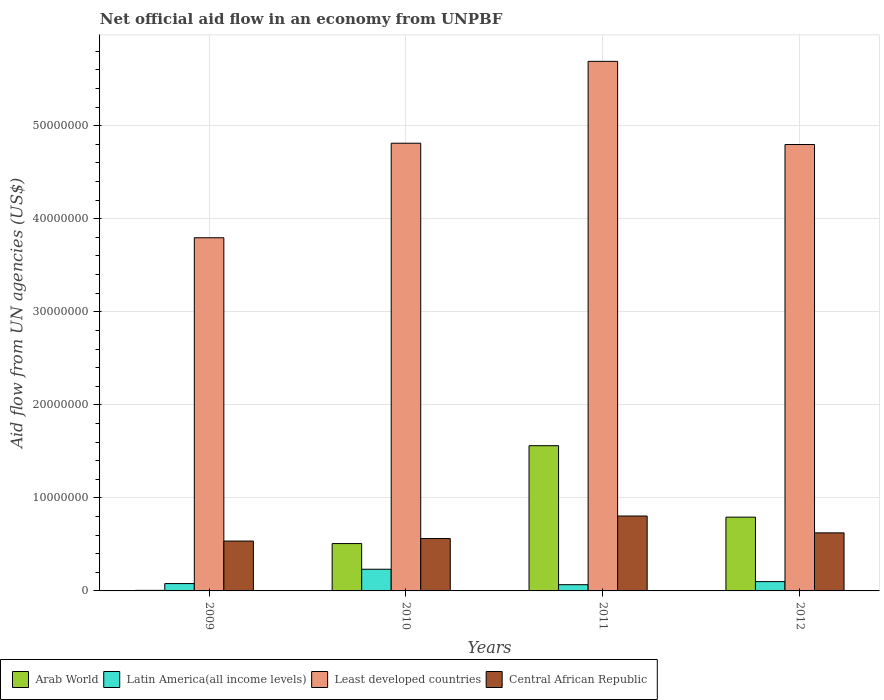How many different coloured bars are there?
Ensure brevity in your answer.  4. How many groups of bars are there?
Offer a very short reply. 4. Are the number of bars per tick equal to the number of legend labels?
Offer a very short reply. Yes. Are the number of bars on each tick of the X-axis equal?
Offer a very short reply. Yes. How many bars are there on the 2nd tick from the left?
Ensure brevity in your answer.  4. What is the label of the 2nd group of bars from the left?
Provide a succinct answer. 2010. In how many cases, is the number of bars for a given year not equal to the number of legend labels?
Your response must be concise. 0. What is the net official aid flow in Central African Republic in 2009?
Offer a very short reply. 5.36e+06. Across all years, what is the maximum net official aid flow in Least developed countries?
Offer a terse response. 5.69e+07. Across all years, what is the minimum net official aid flow in Latin America(all income levels)?
Ensure brevity in your answer.  6.70e+05. In which year was the net official aid flow in Arab World maximum?
Provide a short and direct response. 2011. What is the total net official aid flow in Least developed countries in the graph?
Ensure brevity in your answer.  1.91e+08. What is the difference between the net official aid flow in Central African Republic in 2011 and that in 2012?
Offer a very short reply. 1.81e+06. What is the difference between the net official aid flow in Least developed countries in 2010 and the net official aid flow in Central African Republic in 2009?
Keep it short and to the point. 4.28e+07. What is the average net official aid flow in Arab World per year?
Offer a very short reply. 7.17e+06. In the year 2012, what is the difference between the net official aid flow in Central African Republic and net official aid flow in Latin America(all income levels)?
Your response must be concise. 5.24e+06. What is the ratio of the net official aid flow in Least developed countries in 2011 to that in 2012?
Offer a very short reply. 1.19. What is the difference between the highest and the second highest net official aid flow in Central African Republic?
Your response must be concise. 1.81e+06. What is the difference between the highest and the lowest net official aid flow in Least developed countries?
Your answer should be compact. 1.90e+07. In how many years, is the net official aid flow in Arab World greater than the average net official aid flow in Arab World taken over all years?
Your answer should be compact. 2. Is the sum of the net official aid flow in Latin America(all income levels) in 2011 and 2012 greater than the maximum net official aid flow in Arab World across all years?
Provide a short and direct response. No. What does the 4th bar from the left in 2011 represents?
Provide a short and direct response. Central African Republic. What does the 4th bar from the right in 2009 represents?
Provide a short and direct response. Arab World. Is it the case that in every year, the sum of the net official aid flow in Least developed countries and net official aid flow in Latin America(all income levels) is greater than the net official aid flow in Central African Republic?
Offer a terse response. Yes. How many bars are there?
Keep it short and to the point. 16. What is the difference between two consecutive major ticks on the Y-axis?
Ensure brevity in your answer.  1.00e+07. Does the graph contain any zero values?
Your answer should be compact. No. Does the graph contain grids?
Keep it short and to the point. Yes. Where does the legend appear in the graph?
Your answer should be compact. Bottom left. How many legend labels are there?
Ensure brevity in your answer.  4. How are the legend labels stacked?
Your answer should be very brief. Horizontal. What is the title of the graph?
Offer a terse response. Net official aid flow in an economy from UNPBF. Does "Niger" appear as one of the legend labels in the graph?
Ensure brevity in your answer.  No. What is the label or title of the X-axis?
Offer a terse response. Years. What is the label or title of the Y-axis?
Provide a succinct answer. Aid flow from UN agencies (US$). What is the Aid flow from UN agencies (US$) in Latin America(all income levels) in 2009?
Ensure brevity in your answer.  7.90e+05. What is the Aid flow from UN agencies (US$) of Least developed countries in 2009?
Your answer should be compact. 3.80e+07. What is the Aid flow from UN agencies (US$) in Central African Republic in 2009?
Offer a very short reply. 5.36e+06. What is the Aid flow from UN agencies (US$) in Arab World in 2010?
Offer a very short reply. 5.09e+06. What is the Aid flow from UN agencies (US$) in Latin America(all income levels) in 2010?
Give a very brief answer. 2.33e+06. What is the Aid flow from UN agencies (US$) of Least developed countries in 2010?
Give a very brief answer. 4.81e+07. What is the Aid flow from UN agencies (US$) of Central African Republic in 2010?
Give a very brief answer. 5.63e+06. What is the Aid flow from UN agencies (US$) in Arab World in 2011?
Offer a very short reply. 1.56e+07. What is the Aid flow from UN agencies (US$) in Latin America(all income levels) in 2011?
Provide a succinct answer. 6.70e+05. What is the Aid flow from UN agencies (US$) in Least developed countries in 2011?
Make the answer very short. 5.69e+07. What is the Aid flow from UN agencies (US$) in Central African Republic in 2011?
Your answer should be very brief. 8.05e+06. What is the Aid flow from UN agencies (US$) in Arab World in 2012?
Offer a very short reply. 7.93e+06. What is the Aid flow from UN agencies (US$) in Latin America(all income levels) in 2012?
Your answer should be compact. 1.00e+06. What is the Aid flow from UN agencies (US$) in Least developed countries in 2012?
Provide a short and direct response. 4.80e+07. What is the Aid flow from UN agencies (US$) in Central African Republic in 2012?
Provide a succinct answer. 6.24e+06. Across all years, what is the maximum Aid flow from UN agencies (US$) of Arab World?
Give a very brief answer. 1.56e+07. Across all years, what is the maximum Aid flow from UN agencies (US$) of Latin America(all income levels)?
Give a very brief answer. 2.33e+06. Across all years, what is the maximum Aid flow from UN agencies (US$) in Least developed countries?
Your answer should be compact. 5.69e+07. Across all years, what is the maximum Aid flow from UN agencies (US$) in Central African Republic?
Offer a terse response. 8.05e+06. Across all years, what is the minimum Aid flow from UN agencies (US$) of Arab World?
Make the answer very short. 6.00e+04. Across all years, what is the minimum Aid flow from UN agencies (US$) in Latin America(all income levels)?
Your answer should be compact. 6.70e+05. Across all years, what is the minimum Aid flow from UN agencies (US$) in Least developed countries?
Provide a succinct answer. 3.80e+07. Across all years, what is the minimum Aid flow from UN agencies (US$) in Central African Republic?
Keep it short and to the point. 5.36e+06. What is the total Aid flow from UN agencies (US$) in Arab World in the graph?
Provide a short and direct response. 2.87e+07. What is the total Aid flow from UN agencies (US$) in Latin America(all income levels) in the graph?
Your answer should be very brief. 4.79e+06. What is the total Aid flow from UN agencies (US$) of Least developed countries in the graph?
Offer a terse response. 1.91e+08. What is the total Aid flow from UN agencies (US$) in Central African Republic in the graph?
Your answer should be compact. 2.53e+07. What is the difference between the Aid flow from UN agencies (US$) in Arab World in 2009 and that in 2010?
Give a very brief answer. -5.03e+06. What is the difference between the Aid flow from UN agencies (US$) of Latin America(all income levels) in 2009 and that in 2010?
Keep it short and to the point. -1.54e+06. What is the difference between the Aid flow from UN agencies (US$) in Least developed countries in 2009 and that in 2010?
Your answer should be very brief. -1.02e+07. What is the difference between the Aid flow from UN agencies (US$) of Central African Republic in 2009 and that in 2010?
Offer a terse response. -2.70e+05. What is the difference between the Aid flow from UN agencies (US$) of Arab World in 2009 and that in 2011?
Make the answer very short. -1.56e+07. What is the difference between the Aid flow from UN agencies (US$) of Least developed countries in 2009 and that in 2011?
Your answer should be compact. -1.90e+07. What is the difference between the Aid flow from UN agencies (US$) in Central African Republic in 2009 and that in 2011?
Offer a very short reply. -2.69e+06. What is the difference between the Aid flow from UN agencies (US$) of Arab World in 2009 and that in 2012?
Provide a short and direct response. -7.87e+06. What is the difference between the Aid flow from UN agencies (US$) of Latin America(all income levels) in 2009 and that in 2012?
Your response must be concise. -2.10e+05. What is the difference between the Aid flow from UN agencies (US$) in Least developed countries in 2009 and that in 2012?
Keep it short and to the point. -1.00e+07. What is the difference between the Aid flow from UN agencies (US$) of Central African Republic in 2009 and that in 2012?
Provide a short and direct response. -8.80e+05. What is the difference between the Aid flow from UN agencies (US$) of Arab World in 2010 and that in 2011?
Ensure brevity in your answer.  -1.05e+07. What is the difference between the Aid flow from UN agencies (US$) of Latin America(all income levels) in 2010 and that in 2011?
Keep it short and to the point. 1.66e+06. What is the difference between the Aid flow from UN agencies (US$) in Least developed countries in 2010 and that in 2011?
Offer a terse response. -8.80e+06. What is the difference between the Aid flow from UN agencies (US$) in Central African Republic in 2010 and that in 2011?
Offer a terse response. -2.42e+06. What is the difference between the Aid flow from UN agencies (US$) of Arab World in 2010 and that in 2012?
Ensure brevity in your answer.  -2.84e+06. What is the difference between the Aid flow from UN agencies (US$) in Latin America(all income levels) in 2010 and that in 2012?
Offer a terse response. 1.33e+06. What is the difference between the Aid flow from UN agencies (US$) in Central African Republic in 2010 and that in 2012?
Provide a short and direct response. -6.10e+05. What is the difference between the Aid flow from UN agencies (US$) of Arab World in 2011 and that in 2012?
Provide a succinct answer. 7.68e+06. What is the difference between the Aid flow from UN agencies (US$) of Latin America(all income levels) in 2011 and that in 2012?
Offer a terse response. -3.30e+05. What is the difference between the Aid flow from UN agencies (US$) of Least developed countries in 2011 and that in 2012?
Your response must be concise. 8.94e+06. What is the difference between the Aid flow from UN agencies (US$) of Central African Republic in 2011 and that in 2012?
Offer a very short reply. 1.81e+06. What is the difference between the Aid flow from UN agencies (US$) in Arab World in 2009 and the Aid flow from UN agencies (US$) in Latin America(all income levels) in 2010?
Ensure brevity in your answer.  -2.27e+06. What is the difference between the Aid flow from UN agencies (US$) of Arab World in 2009 and the Aid flow from UN agencies (US$) of Least developed countries in 2010?
Offer a very short reply. -4.81e+07. What is the difference between the Aid flow from UN agencies (US$) in Arab World in 2009 and the Aid flow from UN agencies (US$) in Central African Republic in 2010?
Your response must be concise. -5.57e+06. What is the difference between the Aid flow from UN agencies (US$) in Latin America(all income levels) in 2009 and the Aid flow from UN agencies (US$) in Least developed countries in 2010?
Provide a succinct answer. -4.73e+07. What is the difference between the Aid flow from UN agencies (US$) in Latin America(all income levels) in 2009 and the Aid flow from UN agencies (US$) in Central African Republic in 2010?
Give a very brief answer. -4.84e+06. What is the difference between the Aid flow from UN agencies (US$) in Least developed countries in 2009 and the Aid flow from UN agencies (US$) in Central African Republic in 2010?
Your response must be concise. 3.23e+07. What is the difference between the Aid flow from UN agencies (US$) of Arab World in 2009 and the Aid flow from UN agencies (US$) of Latin America(all income levels) in 2011?
Your answer should be very brief. -6.10e+05. What is the difference between the Aid flow from UN agencies (US$) in Arab World in 2009 and the Aid flow from UN agencies (US$) in Least developed countries in 2011?
Offer a terse response. -5.69e+07. What is the difference between the Aid flow from UN agencies (US$) in Arab World in 2009 and the Aid flow from UN agencies (US$) in Central African Republic in 2011?
Offer a terse response. -7.99e+06. What is the difference between the Aid flow from UN agencies (US$) in Latin America(all income levels) in 2009 and the Aid flow from UN agencies (US$) in Least developed countries in 2011?
Provide a succinct answer. -5.61e+07. What is the difference between the Aid flow from UN agencies (US$) of Latin America(all income levels) in 2009 and the Aid flow from UN agencies (US$) of Central African Republic in 2011?
Offer a very short reply. -7.26e+06. What is the difference between the Aid flow from UN agencies (US$) of Least developed countries in 2009 and the Aid flow from UN agencies (US$) of Central African Republic in 2011?
Offer a terse response. 2.99e+07. What is the difference between the Aid flow from UN agencies (US$) in Arab World in 2009 and the Aid flow from UN agencies (US$) in Latin America(all income levels) in 2012?
Your response must be concise. -9.40e+05. What is the difference between the Aid flow from UN agencies (US$) in Arab World in 2009 and the Aid flow from UN agencies (US$) in Least developed countries in 2012?
Provide a succinct answer. -4.79e+07. What is the difference between the Aid flow from UN agencies (US$) of Arab World in 2009 and the Aid flow from UN agencies (US$) of Central African Republic in 2012?
Ensure brevity in your answer.  -6.18e+06. What is the difference between the Aid flow from UN agencies (US$) in Latin America(all income levels) in 2009 and the Aid flow from UN agencies (US$) in Least developed countries in 2012?
Provide a short and direct response. -4.72e+07. What is the difference between the Aid flow from UN agencies (US$) in Latin America(all income levels) in 2009 and the Aid flow from UN agencies (US$) in Central African Republic in 2012?
Offer a very short reply. -5.45e+06. What is the difference between the Aid flow from UN agencies (US$) in Least developed countries in 2009 and the Aid flow from UN agencies (US$) in Central African Republic in 2012?
Keep it short and to the point. 3.17e+07. What is the difference between the Aid flow from UN agencies (US$) in Arab World in 2010 and the Aid flow from UN agencies (US$) in Latin America(all income levels) in 2011?
Provide a succinct answer. 4.42e+06. What is the difference between the Aid flow from UN agencies (US$) in Arab World in 2010 and the Aid flow from UN agencies (US$) in Least developed countries in 2011?
Offer a very short reply. -5.18e+07. What is the difference between the Aid flow from UN agencies (US$) in Arab World in 2010 and the Aid flow from UN agencies (US$) in Central African Republic in 2011?
Your response must be concise. -2.96e+06. What is the difference between the Aid flow from UN agencies (US$) of Latin America(all income levels) in 2010 and the Aid flow from UN agencies (US$) of Least developed countries in 2011?
Provide a succinct answer. -5.46e+07. What is the difference between the Aid flow from UN agencies (US$) of Latin America(all income levels) in 2010 and the Aid flow from UN agencies (US$) of Central African Republic in 2011?
Your answer should be compact. -5.72e+06. What is the difference between the Aid flow from UN agencies (US$) of Least developed countries in 2010 and the Aid flow from UN agencies (US$) of Central African Republic in 2011?
Provide a succinct answer. 4.01e+07. What is the difference between the Aid flow from UN agencies (US$) in Arab World in 2010 and the Aid flow from UN agencies (US$) in Latin America(all income levels) in 2012?
Provide a succinct answer. 4.09e+06. What is the difference between the Aid flow from UN agencies (US$) in Arab World in 2010 and the Aid flow from UN agencies (US$) in Least developed countries in 2012?
Give a very brief answer. -4.29e+07. What is the difference between the Aid flow from UN agencies (US$) in Arab World in 2010 and the Aid flow from UN agencies (US$) in Central African Republic in 2012?
Offer a very short reply. -1.15e+06. What is the difference between the Aid flow from UN agencies (US$) of Latin America(all income levels) in 2010 and the Aid flow from UN agencies (US$) of Least developed countries in 2012?
Your answer should be compact. -4.56e+07. What is the difference between the Aid flow from UN agencies (US$) of Latin America(all income levels) in 2010 and the Aid flow from UN agencies (US$) of Central African Republic in 2012?
Your answer should be compact. -3.91e+06. What is the difference between the Aid flow from UN agencies (US$) of Least developed countries in 2010 and the Aid flow from UN agencies (US$) of Central African Republic in 2012?
Make the answer very short. 4.19e+07. What is the difference between the Aid flow from UN agencies (US$) in Arab World in 2011 and the Aid flow from UN agencies (US$) in Latin America(all income levels) in 2012?
Offer a terse response. 1.46e+07. What is the difference between the Aid flow from UN agencies (US$) of Arab World in 2011 and the Aid flow from UN agencies (US$) of Least developed countries in 2012?
Offer a terse response. -3.24e+07. What is the difference between the Aid flow from UN agencies (US$) in Arab World in 2011 and the Aid flow from UN agencies (US$) in Central African Republic in 2012?
Keep it short and to the point. 9.37e+06. What is the difference between the Aid flow from UN agencies (US$) in Latin America(all income levels) in 2011 and the Aid flow from UN agencies (US$) in Least developed countries in 2012?
Your response must be concise. -4.73e+07. What is the difference between the Aid flow from UN agencies (US$) of Latin America(all income levels) in 2011 and the Aid flow from UN agencies (US$) of Central African Republic in 2012?
Your response must be concise. -5.57e+06. What is the difference between the Aid flow from UN agencies (US$) of Least developed countries in 2011 and the Aid flow from UN agencies (US$) of Central African Republic in 2012?
Offer a terse response. 5.07e+07. What is the average Aid flow from UN agencies (US$) of Arab World per year?
Ensure brevity in your answer.  7.17e+06. What is the average Aid flow from UN agencies (US$) of Latin America(all income levels) per year?
Provide a succinct answer. 1.20e+06. What is the average Aid flow from UN agencies (US$) in Least developed countries per year?
Give a very brief answer. 4.77e+07. What is the average Aid flow from UN agencies (US$) in Central African Republic per year?
Give a very brief answer. 6.32e+06. In the year 2009, what is the difference between the Aid flow from UN agencies (US$) of Arab World and Aid flow from UN agencies (US$) of Latin America(all income levels)?
Keep it short and to the point. -7.30e+05. In the year 2009, what is the difference between the Aid flow from UN agencies (US$) of Arab World and Aid flow from UN agencies (US$) of Least developed countries?
Your answer should be compact. -3.79e+07. In the year 2009, what is the difference between the Aid flow from UN agencies (US$) in Arab World and Aid flow from UN agencies (US$) in Central African Republic?
Your answer should be very brief. -5.30e+06. In the year 2009, what is the difference between the Aid flow from UN agencies (US$) in Latin America(all income levels) and Aid flow from UN agencies (US$) in Least developed countries?
Keep it short and to the point. -3.72e+07. In the year 2009, what is the difference between the Aid flow from UN agencies (US$) of Latin America(all income levels) and Aid flow from UN agencies (US$) of Central African Republic?
Your answer should be compact. -4.57e+06. In the year 2009, what is the difference between the Aid flow from UN agencies (US$) of Least developed countries and Aid flow from UN agencies (US$) of Central African Republic?
Your answer should be compact. 3.26e+07. In the year 2010, what is the difference between the Aid flow from UN agencies (US$) of Arab World and Aid flow from UN agencies (US$) of Latin America(all income levels)?
Ensure brevity in your answer.  2.76e+06. In the year 2010, what is the difference between the Aid flow from UN agencies (US$) in Arab World and Aid flow from UN agencies (US$) in Least developed countries?
Provide a succinct answer. -4.30e+07. In the year 2010, what is the difference between the Aid flow from UN agencies (US$) in Arab World and Aid flow from UN agencies (US$) in Central African Republic?
Provide a short and direct response. -5.40e+05. In the year 2010, what is the difference between the Aid flow from UN agencies (US$) in Latin America(all income levels) and Aid flow from UN agencies (US$) in Least developed countries?
Ensure brevity in your answer.  -4.58e+07. In the year 2010, what is the difference between the Aid flow from UN agencies (US$) of Latin America(all income levels) and Aid flow from UN agencies (US$) of Central African Republic?
Ensure brevity in your answer.  -3.30e+06. In the year 2010, what is the difference between the Aid flow from UN agencies (US$) of Least developed countries and Aid flow from UN agencies (US$) of Central African Republic?
Provide a short and direct response. 4.25e+07. In the year 2011, what is the difference between the Aid flow from UN agencies (US$) in Arab World and Aid flow from UN agencies (US$) in Latin America(all income levels)?
Your response must be concise. 1.49e+07. In the year 2011, what is the difference between the Aid flow from UN agencies (US$) of Arab World and Aid flow from UN agencies (US$) of Least developed countries?
Your answer should be very brief. -4.13e+07. In the year 2011, what is the difference between the Aid flow from UN agencies (US$) in Arab World and Aid flow from UN agencies (US$) in Central African Republic?
Make the answer very short. 7.56e+06. In the year 2011, what is the difference between the Aid flow from UN agencies (US$) of Latin America(all income levels) and Aid flow from UN agencies (US$) of Least developed countries?
Make the answer very short. -5.62e+07. In the year 2011, what is the difference between the Aid flow from UN agencies (US$) in Latin America(all income levels) and Aid flow from UN agencies (US$) in Central African Republic?
Make the answer very short. -7.38e+06. In the year 2011, what is the difference between the Aid flow from UN agencies (US$) of Least developed countries and Aid flow from UN agencies (US$) of Central African Republic?
Your answer should be very brief. 4.89e+07. In the year 2012, what is the difference between the Aid flow from UN agencies (US$) of Arab World and Aid flow from UN agencies (US$) of Latin America(all income levels)?
Offer a very short reply. 6.93e+06. In the year 2012, what is the difference between the Aid flow from UN agencies (US$) of Arab World and Aid flow from UN agencies (US$) of Least developed countries?
Provide a succinct answer. -4.00e+07. In the year 2012, what is the difference between the Aid flow from UN agencies (US$) of Arab World and Aid flow from UN agencies (US$) of Central African Republic?
Your response must be concise. 1.69e+06. In the year 2012, what is the difference between the Aid flow from UN agencies (US$) of Latin America(all income levels) and Aid flow from UN agencies (US$) of Least developed countries?
Offer a terse response. -4.70e+07. In the year 2012, what is the difference between the Aid flow from UN agencies (US$) of Latin America(all income levels) and Aid flow from UN agencies (US$) of Central African Republic?
Provide a succinct answer. -5.24e+06. In the year 2012, what is the difference between the Aid flow from UN agencies (US$) in Least developed countries and Aid flow from UN agencies (US$) in Central African Republic?
Offer a terse response. 4.17e+07. What is the ratio of the Aid flow from UN agencies (US$) of Arab World in 2009 to that in 2010?
Provide a short and direct response. 0.01. What is the ratio of the Aid flow from UN agencies (US$) of Latin America(all income levels) in 2009 to that in 2010?
Keep it short and to the point. 0.34. What is the ratio of the Aid flow from UN agencies (US$) of Least developed countries in 2009 to that in 2010?
Give a very brief answer. 0.79. What is the ratio of the Aid flow from UN agencies (US$) in Arab World in 2009 to that in 2011?
Keep it short and to the point. 0. What is the ratio of the Aid flow from UN agencies (US$) of Latin America(all income levels) in 2009 to that in 2011?
Ensure brevity in your answer.  1.18. What is the ratio of the Aid flow from UN agencies (US$) of Least developed countries in 2009 to that in 2011?
Provide a succinct answer. 0.67. What is the ratio of the Aid flow from UN agencies (US$) of Central African Republic in 2009 to that in 2011?
Ensure brevity in your answer.  0.67. What is the ratio of the Aid flow from UN agencies (US$) of Arab World in 2009 to that in 2012?
Ensure brevity in your answer.  0.01. What is the ratio of the Aid flow from UN agencies (US$) of Latin America(all income levels) in 2009 to that in 2012?
Give a very brief answer. 0.79. What is the ratio of the Aid flow from UN agencies (US$) of Least developed countries in 2009 to that in 2012?
Offer a terse response. 0.79. What is the ratio of the Aid flow from UN agencies (US$) in Central African Republic in 2009 to that in 2012?
Keep it short and to the point. 0.86. What is the ratio of the Aid flow from UN agencies (US$) in Arab World in 2010 to that in 2011?
Keep it short and to the point. 0.33. What is the ratio of the Aid flow from UN agencies (US$) of Latin America(all income levels) in 2010 to that in 2011?
Make the answer very short. 3.48. What is the ratio of the Aid flow from UN agencies (US$) in Least developed countries in 2010 to that in 2011?
Ensure brevity in your answer.  0.85. What is the ratio of the Aid flow from UN agencies (US$) in Central African Republic in 2010 to that in 2011?
Provide a short and direct response. 0.7. What is the ratio of the Aid flow from UN agencies (US$) in Arab World in 2010 to that in 2012?
Your response must be concise. 0.64. What is the ratio of the Aid flow from UN agencies (US$) in Latin America(all income levels) in 2010 to that in 2012?
Ensure brevity in your answer.  2.33. What is the ratio of the Aid flow from UN agencies (US$) of Least developed countries in 2010 to that in 2012?
Provide a short and direct response. 1. What is the ratio of the Aid flow from UN agencies (US$) in Central African Republic in 2010 to that in 2012?
Offer a terse response. 0.9. What is the ratio of the Aid flow from UN agencies (US$) in Arab World in 2011 to that in 2012?
Make the answer very short. 1.97. What is the ratio of the Aid flow from UN agencies (US$) of Latin America(all income levels) in 2011 to that in 2012?
Give a very brief answer. 0.67. What is the ratio of the Aid flow from UN agencies (US$) of Least developed countries in 2011 to that in 2012?
Keep it short and to the point. 1.19. What is the ratio of the Aid flow from UN agencies (US$) in Central African Republic in 2011 to that in 2012?
Your answer should be very brief. 1.29. What is the difference between the highest and the second highest Aid flow from UN agencies (US$) of Arab World?
Make the answer very short. 7.68e+06. What is the difference between the highest and the second highest Aid flow from UN agencies (US$) in Latin America(all income levels)?
Offer a very short reply. 1.33e+06. What is the difference between the highest and the second highest Aid flow from UN agencies (US$) of Least developed countries?
Your answer should be compact. 8.80e+06. What is the difference between the highest and the second highest Aid flow from UN agencies (US$) in Central African Republic?
Provide a short and direct response. 1.81e+06. What is the difference between the highest and the lowest Aid flow from UN agencies (US$) in Arab World?
Ensure brevity in your answer.  1.56e+07. What is the difference between the highest and the lowest Aid flow from UN agencies (US$) in Latin America(all income levels)?
Keep it short and to the point. 1.66e+06. What is the difference between the highest and the lowest Aid flow from UN agencies (US$) of Least developed countries?
Your response must be concise. 1.90e+07. What is the difference between the highest and the lowest Aid flow from UN agencies (US$) in Central African Republic?
Keep it short and to the point. 2.69e+06. 